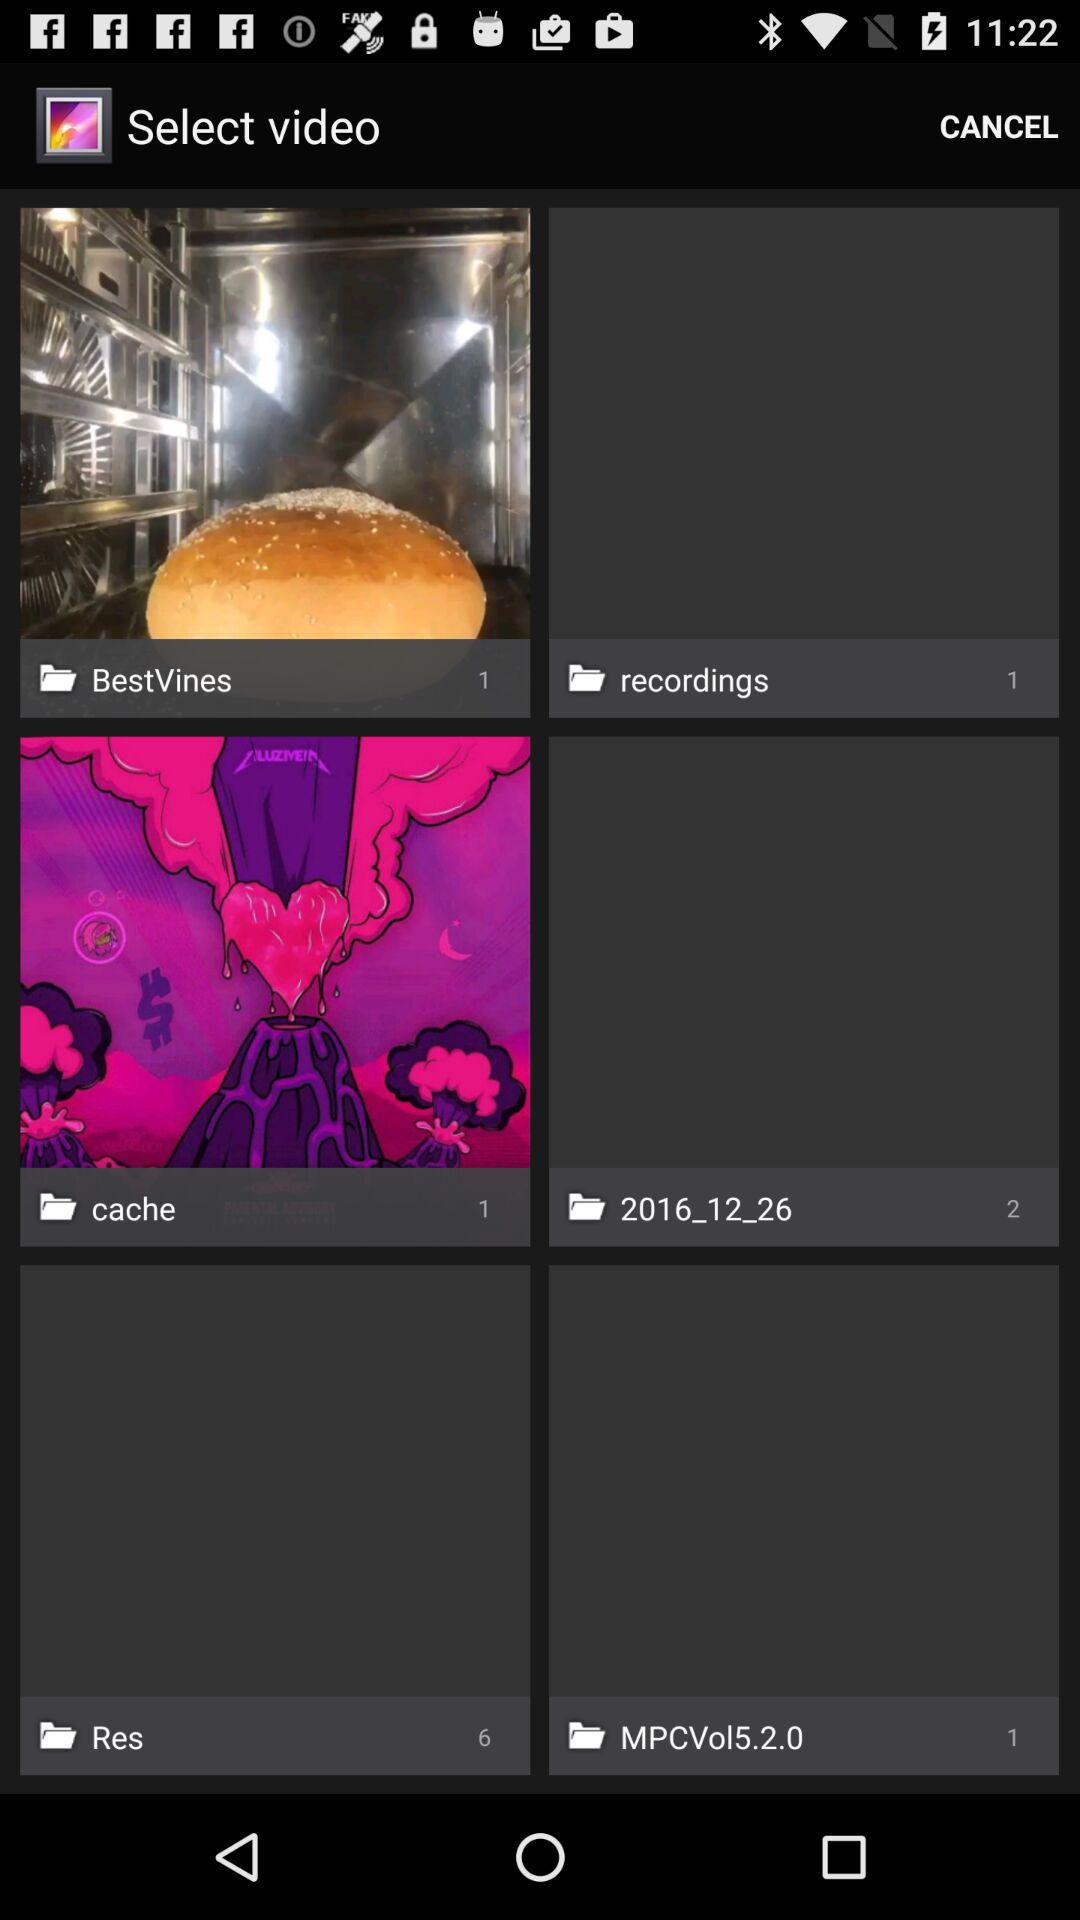What is the number of files in "cache"? The number of files in "cache" is 1. 